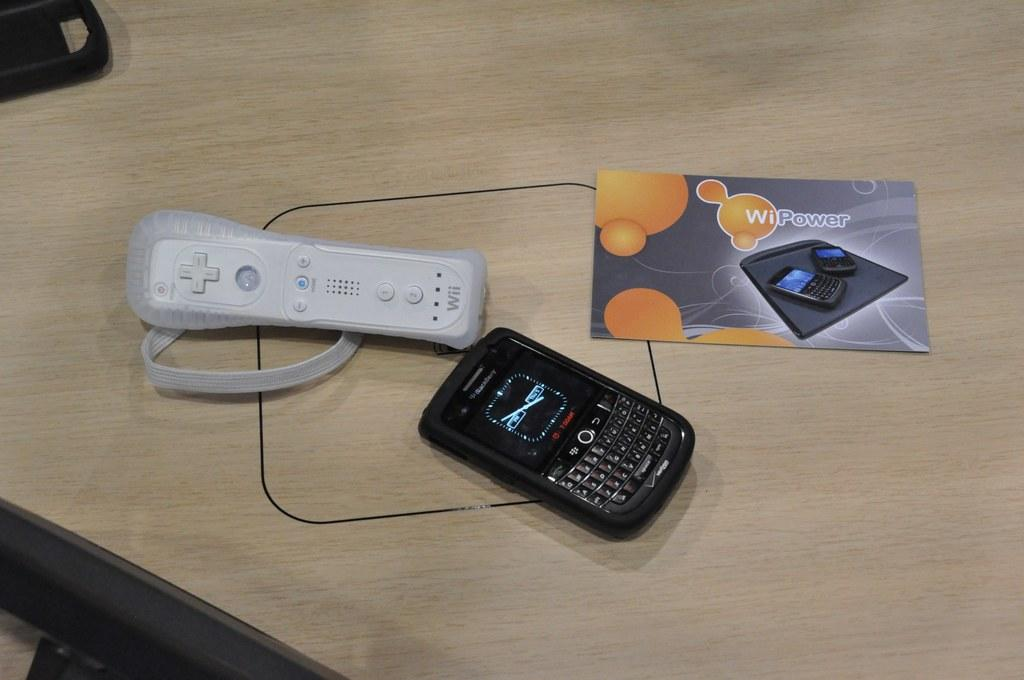Provide a one-sentence caption for the provided image. a wii remote, black blackberry phone and paper on the top of table. 